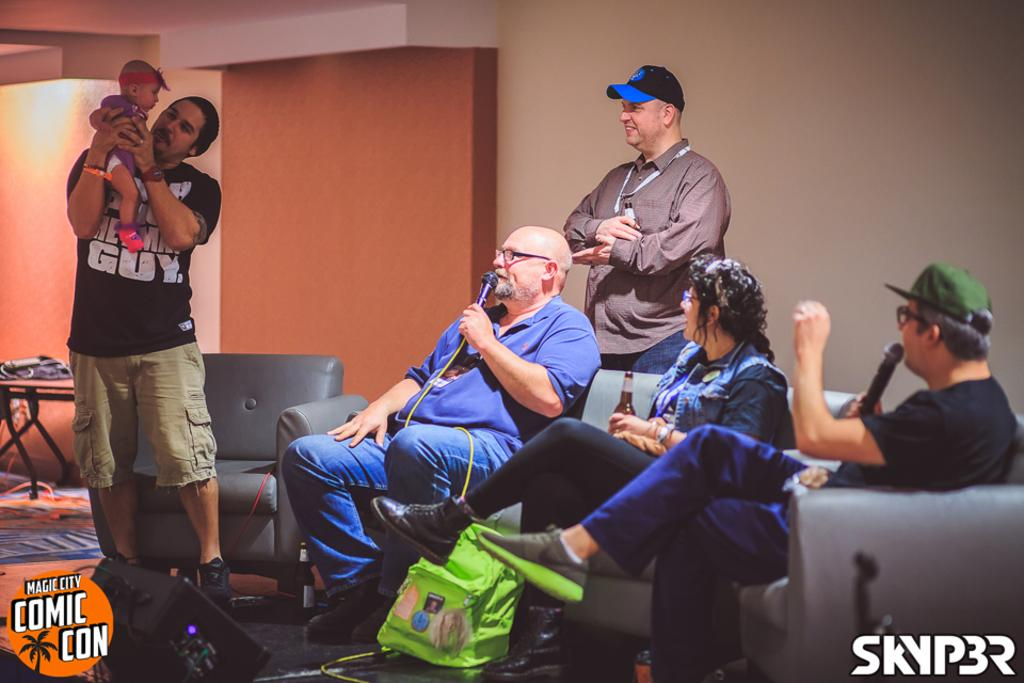What are the people in the image doing? There are people sitting on a sofa in the image. Are there any other individuals in the image besides those sitting on the sofa? Yes, there are two men standing in the image. What can be seen in the background of the image? There is a wall in the background of the image. What type of mine is visible in the image? There is no mine present in the image. Can you hear the men laughing in the image? The image is a still picture, so it does not capture sound. Therefore, we cannot hear the men laughing in the image. 